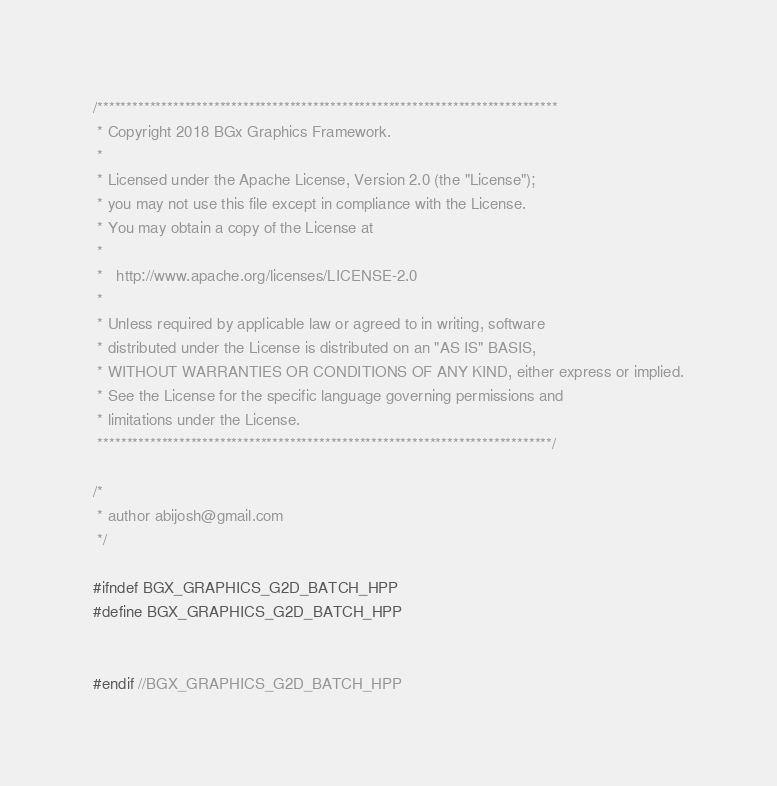<code> <loc_0><loc_0><loc_500><loc_500><_C++_>/*******************************************************************************
 * Copyright 2018 BGx Graphics Framework.
 * 
 * Licensed under the Apache License, Version 2.0 (the "License");
 * you may not use this file except in compliance with the License.
 * You may obtain a copy of the License at
 * 
 *   http://www.apache.org/licenses/LICENSE-2.0
 * 
 * Unless required by applicable law or agreed to in writing, software
 * distributed under the License is distributed on an "AS IS" BASIS,
 * WITHOUT WARRANTIES OR CONDITIONS OF ANY KIND, either express or implied.
 * See the License for the specific language governing permissions and
 * limitations under the License.
 ******************************************************************************/

/*
 * author abijosh@gmail.com
 */

#ifndef BGX_GRAPHICS_G2D_BATCH_HPP
#define BGX_GRAPHICS_G2D_BATCH_HPP


#endif //BGX_GRAPHICS_G2D_BATCH_HPP</code> 